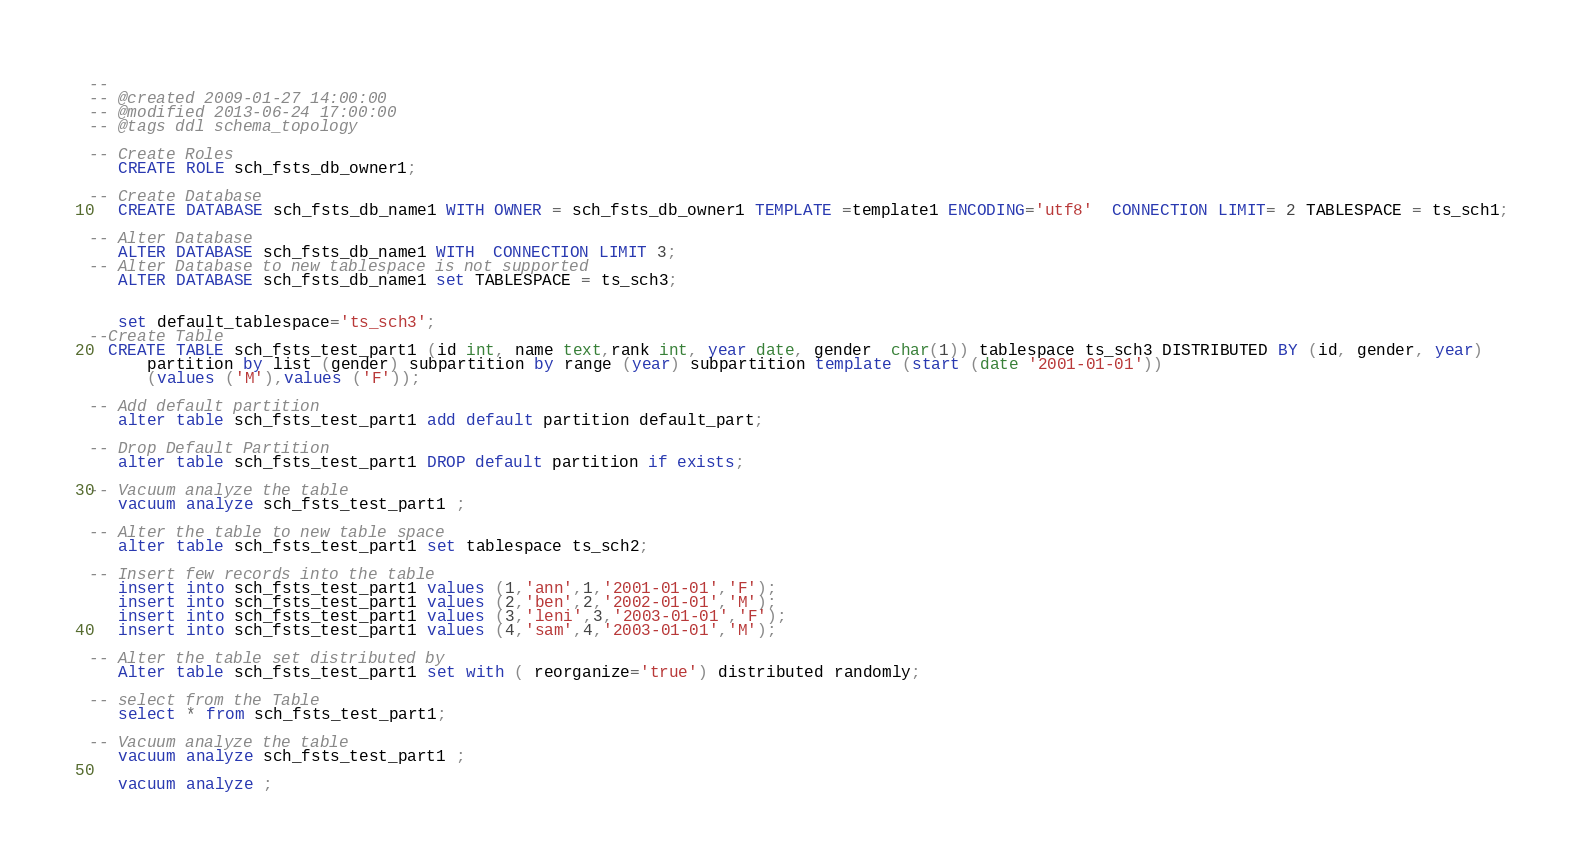<code> <loc_0><loc_0><loc_500><loc_500><_SQL_>-- 
-- @created 2009-01-27 14:00:00
-- @modified 2013-06-24 17:00:00
-- @tags ddl schema_topology

-- Create Roles   
   CREATE ROLE sch_fsts_db_owner1;

-- Create Database
   CREATE DATABASE sch_fsts_db_name1 WITH OWNER = sch_fsts_db_owner1 TEMPLATE =template1 ENCODING='utf8'  CONNECTION LIMIT= 2 TABLESPACE = ts_sch1;
   
-- Alter Database   
   ALTER DATABASE sch_fsts_db_name1 WITH  CONNECTION LIMIT 3;
-- Alter Database to new tablespace is not supported  
   ALTER DATABASE sch_fsts_db_name1 set TABLESPACE = ts_sch3;


   set default_tablespace='ts_sch3';
--Create Table   
  CREATE TABLE sch_fsts_test_part1 (id int, name text,rank int, year date, gender  char(1)) tablespace ts_sch3 DISTRIBUTED BY (id, gender, year)
      partition by list (gender) subpartition by range (year) subpartition template (start (date '2001-01-01')) 
      (values ('M'),values ('F'));

-- Add default partition
   alter table sch_fsts_test_part1 add default partition default_part;

-- Drop Default Partition
   alter table sch_fsts_test_part1 DROP default partition if exists;

-- Vacuum analyze the table
   vacuum analyze sch_fsts_test_part1 ;

-- Alter the table to new table space 
   alter table sch_fsts_test_part1 set tablespace ts_sch2;

-- Insert few records into the table
   insert into sch_fsts_test_part1 values (1,'ann',1,'2001-01-01','F');
   insert into sch_fsts_test_part1 values (2,'ben',2,'2002-01-01','M');
   insert into sch_fsts_test_part1 values (3,'leni',3,'2003-01-01','F');
   insert into sch_fsts_test_part1 values (4,'sam',4,'2003-01-01','M');

-- Alter the table set distributed by 
   Alter table sch_fsts_test_part1 set with ( reorganize='true') distributed randomly;

-- select from the Table
   select * from sch_fsts_test_part1;

-- Vacuum analyze the table
   vacuum analyze sch_fsts_test_part1 ;

   vacuum analyze ;
</code> 